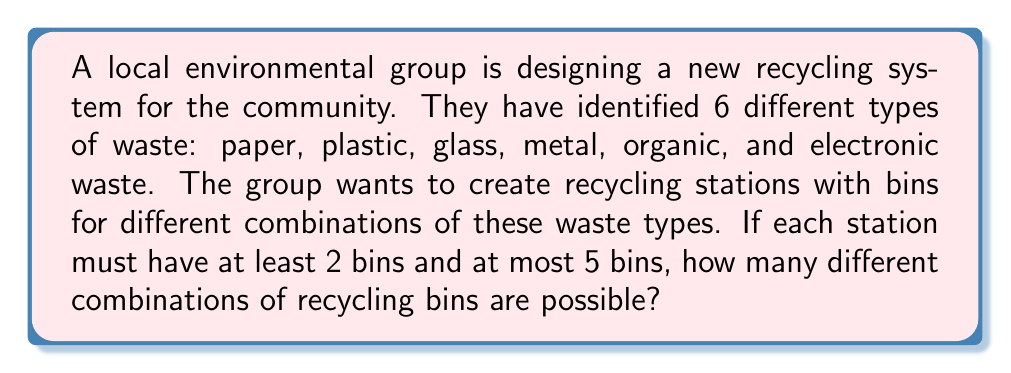Give your solution to this math problem. Let's approach this step-by-step:

1) We need to calculate the number of combinations for 2, 3, 4, and 5 bins out of 6 waste types.

2) This is a combination problem, where the order doesn't matter (e.g., a station with paper and plastic is the same as plastic and paper).

3) We use the combination formula: $C(n,r) = \frac{n!}{r!(n-r)!}$, where $n$ is the total number of items to choose from, and $r$ is the number being chosen.

4) Let's calculate for each bin count:

   For 2 bins: $C(6,2) = \frac{6!}{2!(6-2)!} = \frac{6!}{2!4!} = 15$

   For 3 bins: $C(6,3) = \frac{6!}{3!(6-3)!} = \frac{6!}{3!3!} = 20$

   For 4 bins: $C(6,4) = \frac{6!}{4!(6-4)!} = \frac{6!}{4!2!} = 15$

   For 5 bins: $C(6,5) = \frac{6!}{5!(6-5)!} = \frac{6!}{5!1!} = 6$

5) To get the total number of possible combinations, we sum these results:

   $15 + 20 + 15 + 6 = 56$

Therefore, there are 56 different possible combinations of recycling bins.
Answer: 56 